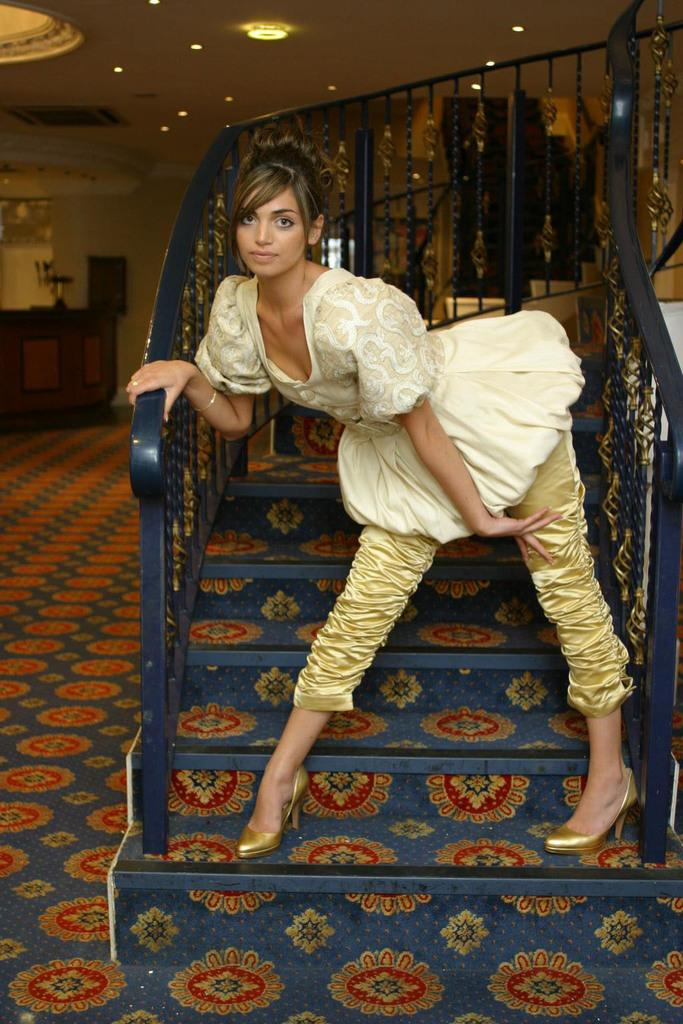Who is present in the image? There is a woman in the image. What is the woman doing in the image? The woman is standing on a staircase. What can be seen in the background of the image? There are cupboards, a wall, a ceiling, and lights in the background of the image. What type of zephyr can be seen blowing through the field in the image? There is no field or zephyr present in the image. 